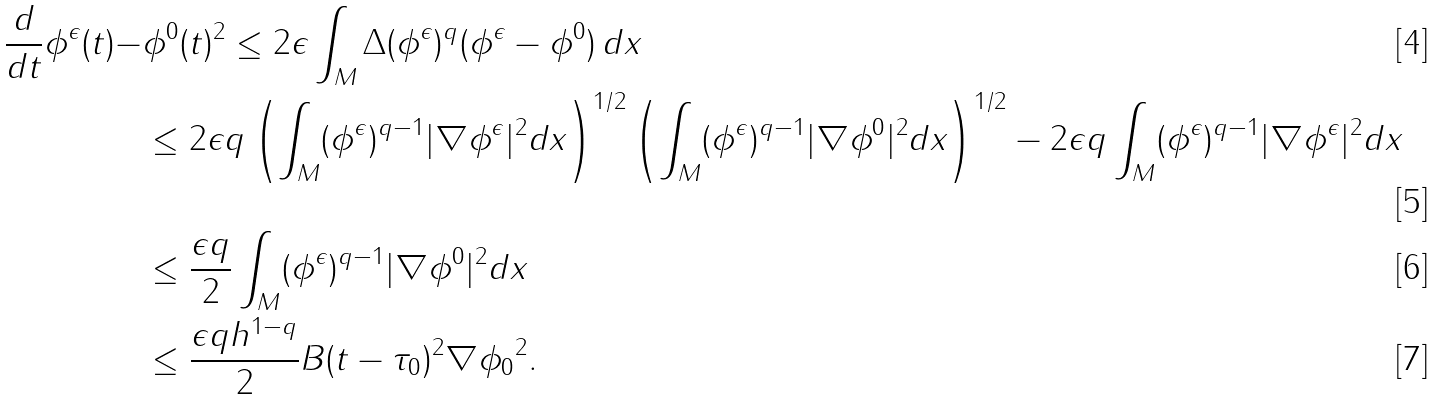Convert formula to latex. <formula><loc_0><loc_0><loc_500><loc_500>\frac { d } { d t } \| \phi ^ { \epsilon } ( t ) - & \phi ^ { 0 } ( t ) \| ^ { 2 } \leq 2 \epsilon \int _ { M } \Delta ( \phi ^ { \epsilon } ) ^ { q } ( \phi ^ { \epsilon } - \phi ^ { 0 } ) \, d x \\ & \leq 2 \epsilon q \left ( \int _ { M } ( \phi ^ { \epsilon } ) ^ { q - 1 } | \nabla \phi ^ { \epsilon } | ^ { 2 } d x \right ) ^ { 1 / 2 } \left ( \int _ { M } ( \phi ^ { \epsilon } ) ^ { q - 1 } | \nabla \phi ^ { 0 } | ^ { 2 } d x \right ) ^ { 1 / 2 } - 2 \epsilon q \int _ { M } ( \phi ^ { \epsilon } ) ^ { q - 1 } | \nabla \phi ^ { \epsilon } | ^ { 2 } d x \\ & \leq \frac { \epsilon q } { 2 } \int _ { M } ( \phi ^ { \epsilon } ) ^ { q - 1 } | \nabla \phi ^ { 0 } | ^ { 2 } d x \\ & \leq \frac { \epsilon q h ^ { 1 - q } } { 2 } B ( t - \tau _ { 0 } ) ^ { 2 } \| \nabla \phi _ { 0 } \| ^ { 2 } .</formula> 